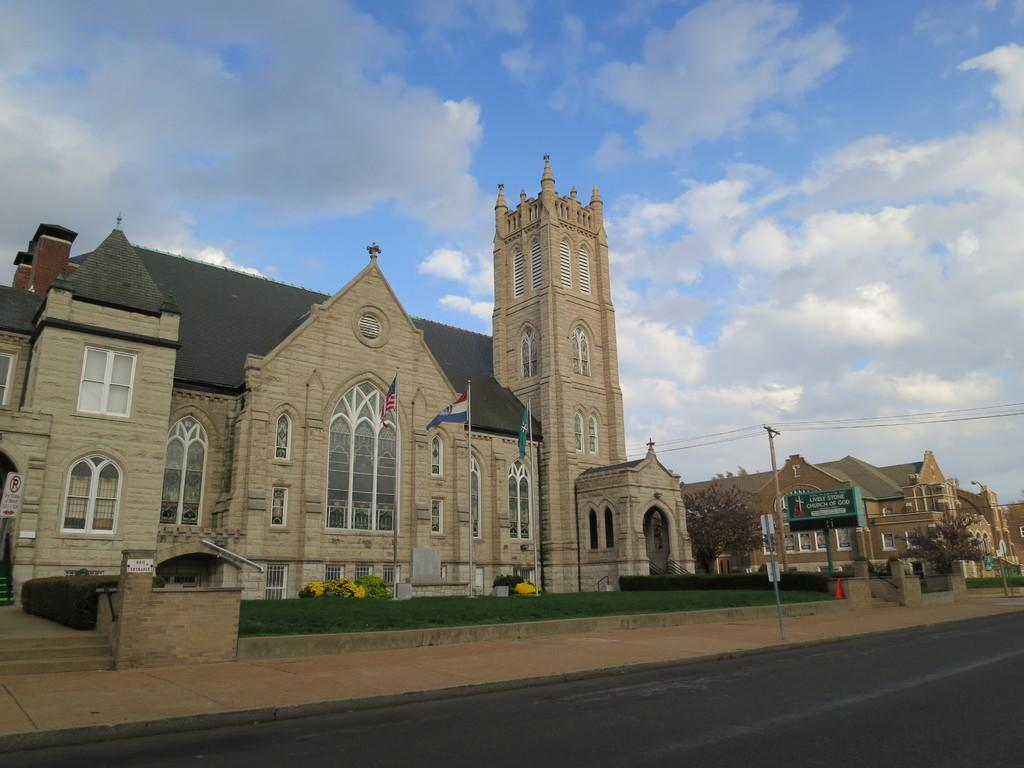What is located in the center of the image? There are buildings and flags in the center of the image. What can be seen in the sky in the image? The sky is visible at the top of the image. What is present at the bottom of the image? There is a road at the bottom of the image. How many ants can be seen carrying books on the road in the image? There are no ants or books present on the road in the image. What type of goat is grazing on the grass near the buildings in the image? There are no goats present near the buildings in the image. 